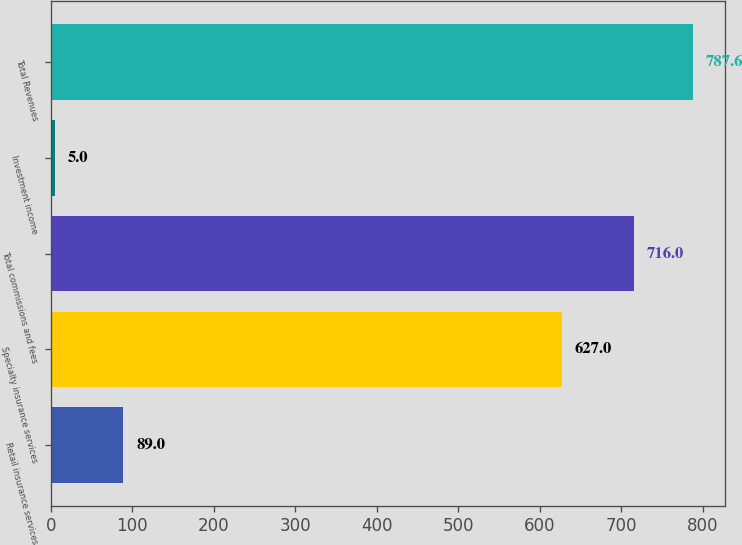<chart> <loc_0><loc_0><loc_500><loc_500><bar_chart><fcel>Retail insurance services<fcel>Specialty insurance services<fcel>Total commissions and fees<fcel>Investment income<fcel>Total Revenues<nl><fcel>89<fcel>627<fcel>716<fcel>5<fcel>787.6<nl></chart> 